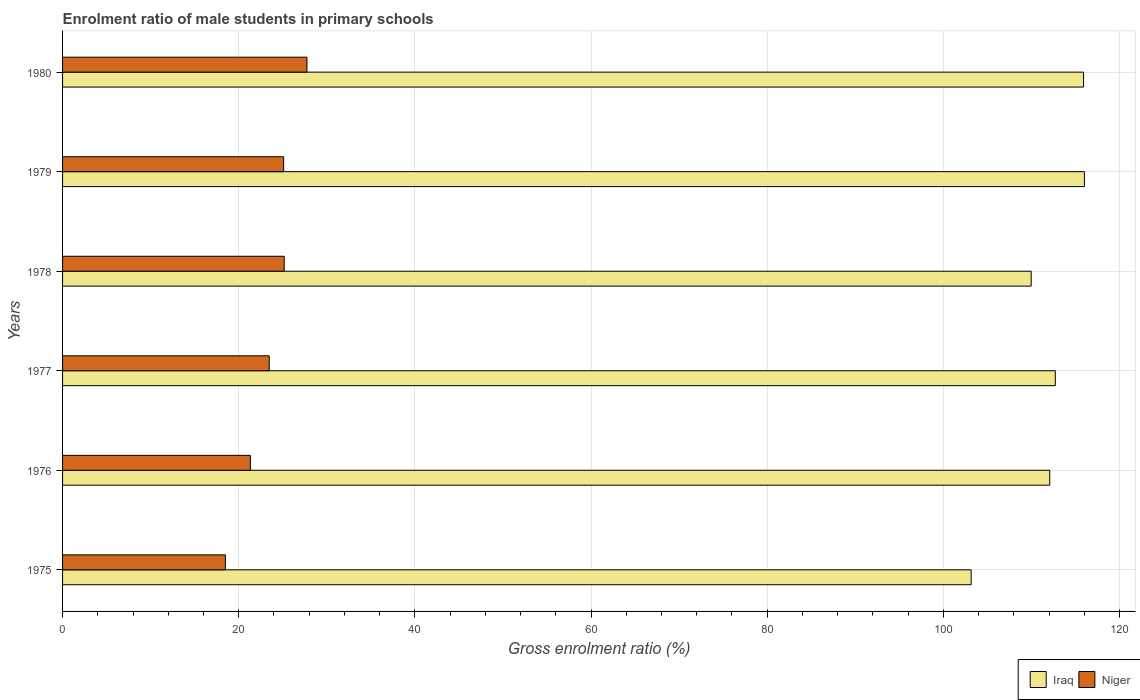How many different coloured bars are there?
Ensure brevity in your answer.  2. How many groups of bars are there?
Your answer should be very brief. 6. Are the number of bars on each tick of the Y-axis equal?
Give a very brief answer. Yes. In how many cases, is the number of bars for a given year not equal to the number of legend labels?
Offer a terse response. 0. What is the enrolment ratio of male students in primary schools in Niger in 1979?
Offer a terse response. 25.1. Across all years, what is the maximum enrolment ratio of male students in primary schools in Iraq?
Your answer should be very brief. 116.01. Across all years, what is the minimum enrolment ratio of male students in primary schools in Niger?
Ensure brevity in your answer.  18.49. In which year was the enrolment ratio of male students in primary schools in Niger maximum?
Offer a terse response. 1980. In which year was the enrolment ratio of male students in primary schools in Niger minimum?
Your answer should be compact. 1975. What is the total enrolment ratio of male students in primary schools in Iraq in the graph?
Keep it short and to the point. 669.84. What is the difference between the enrolment ratio of male students in primary schools in Niger in 1976 and that in 1980?
Ensure brevity in your answer.  -6.42. What is the difference between the enrolment ratio of male students in primary schools in Niger in 1980 and the enrolment ratio of male students in primary schools in Iraq in 1976?
Make the answer very short. -84.33. What is the average enrolment ratio of male students in primary schools in Iraq per year?
Your answer should be very brief. 111.64. In the year 1975, what is the difference between the enrolment ratio of male students in primary schools in Niger and enrolment ratio of male students in primary schools in Iraq?
Make the answer very short. -84.67. What is the ratio of the enrolment ratio of male students in primary schools in Iraq in 1976 to that in 1978?
Give a very brief answer. 1.02. What is the difference between the highest and the second highest enrolment ratio of male students in primary schools in Niger?
Ensure brevity in your answer.  2.58. What is the difference between the highest and the lowest enrolment ratio of male students in primary schools in Iraq?
Ensure brevity in your answer.  12.86. In how many years, is the enrolment ratio of male students in primary schools in Iraq greater than the average enrolment ratio of male students in primary schools in Iraq taken over all years?
Provide a succinct answer. 4. Is the sum of the enrolment ratio of male students in primary schools in Niger in 1976 and 1978 greater than the maximum enrolment ratio of male students in primary schools in Iraq across all years?
Offer a terse response. No. What does the 1st bar from the top in 1975 represents?
Provide a short and direct response. Niger. What does the 2nd bar from the bottom in 1977 represents?
Offer a terse response. Niger. How many bars are there?
Offer a very short reply. 12. Are all the bars in the graph horizontal?
Give a very brief answer. Yes. How many years are there in the graph?
Your answer should be compact. 6. What is the difference between two consecutive major ticks on the X-axis?
Make the answer very short. 20. Does the graph contain any zero values?
Your response must be concise. No. Does the graph contain grids?
Make the answer very short. Yes. Where does the legend appear in the graph?
Give a very brief answer. Bottom right. How many legend labels are there?
Provide a succinct answer. 2. How are the legend labels stacked?
Your answer should be compact. Horizontal. What is the title of the graph?
Offer a very short reply. Enrolment ratio of male students in primary schools. What is the label or title of the X-axis?
Make the answer very short. Gross enrolment ratio (%). What is the label or title of the Y-axis?
Your answer should be very brief. Years. What is the Gross enrolment ratio (%) in Iraq in 1975?
Make the answer very short. 103.15. What is the Gross enrolment ratio (%) in Niger in 1975?
Ensure brevity in your answer.  18.49. What is the Gross enrolment ratio (%) in Iraq in 1976?
Offer a terse response. 112.08. What is the Gross enrolment ratio (%) in Niger in 1976?
Offer a very short reply. 21.32. What is the Gross enrolment ratio (%) in Iraq in 1977?
Provide a short and direct response. 112.71. What is the Gross enrolment ratio (%) of Niger in 1977?
Keep it short and to the point. 23.46. What is the Gross enrolment ratio (%) in Iraq in 1978?
Give a very brief answer. 109.97. What is the Gross enrolment ratio (%) of Niger in 1978?
Your response must be concise. 25.16. What is the Gross enrolment ratio (%) in Iraq in 1979?
Your response must be concise. 116.01. What is the Gross enrolment ratio (%) in Niger in 1979?
Keep it short and to the point. 25.1. What is the Gross enrolment ratio (%) in Iraq in 1980?
Offer a very short reply. 115.92. What is the Gross enrolment ratio (%) of Niger in 1980?
Provide a succinct answer. 27.75. Across all years, what is the maximum Gross enrolment ratio (%) in Iraq?
Ensure brevity in your answer.  116.01. Across all years, what is the maximum Gross enrolment ratio (%) in Niger?
Your answer should be compact. 27.75. Across all years, what is the minimum Gross enrolment ratio (%) in Iraq?
Keep it short and to the point. 103.15. Across all years, what is the minimum Gross enrolment ratio (%) of Niger?
Keep it short and to the point. 18.49. What is the total Gross enrolment ratio (%) of Iraq in the graph?
Your response must be concise. 669.84. What is the total Gross enrolment ratio (%) of Niger in the graph?
Keep it short and to the point. 141.28. What is the difference between the Gross enrolment ratio (%) in Iraq in 1975 and that in 1976?
Offer a terse response. -8.92. What is the difference between the Gross enrolment ratio (%) of Niger in 1975 and that in 1976?
Offer a terse response. -2.84. What is the difference between the Gross enrolment ratio (%) of Iraq in 1975 and that in 1977?
Make the answer very short. -9.55. What is the difference between the Gross enrolment ratio (%) in Niger in 1975 and that in 1977?
Provide a short and direct response. -4.98. What is the difference between the Gross enrolment ratio (%) in Iraq in 1975 and that in 1978?
Your response must be concise. -6.81. What is the difference between the Gross enrolment ratio (%) in Niger in 1975 and that in 1978?
Keep it short and to the point. -6.68. What is the difference between the Gross enrolment ratio (%) in Iraq in 1975 and that in 1979?
Provide a short and direct response. -12.86. What is the difference between the Gross enrolment ratio (%) in Niger in 1975 and that in 1979?
Make the answer very short. -6.61. What is the difference between the Gross enrolment ratio (%) of Iraq in 1975 and that in 1980?
Give a very brief answer. -12.76. What is the difference between the Gross enrolment ratio (%) of Niger in 1975 and that in 1980?
Your answer should be very brief. -9.26. What is the difference between the Gross enrolment ratio (%) of Iraq in 1976 and that in 1977?
Provide a short and direct response. -0.63. What is the difference between the Gross enrolment ratio (%) in Niger in 1976 and that in 1977?
Give a very brief answer. -2.14. What is the difference between the Gross enrolment ratio (%) in Iraq in 1976 and that in 1978?
Your response must be concise. 2.11. What is the difference between the Gross enrolment ratio (%) in Niger in 1976 and that in 1978?
Your answer should be compact. -3.84. What is the difference between the Gross enrolment ratio (%) in Iraq in 1976 and that in 1979?
Your answer should be compact. -3.93. What is the difference between the Gross enrolment ratio (%) in Niger in 1976 and that in 1979?
Provide a succinct answer. -3.78. What is the difference between the Gross enrolment ratio (%) in Iraq in 1976 and that in 1980?
Keep it short and to the point. -3.84. What is the difference between the Gross enrolment ratio (%) of Niger in 1976 and that in 1980?
Your response must be concise. -6.42. What is the difference between the Gross enrolment ratio (%) of Iraq in 1977 and that in 1978?
Give a very brief answer. 2.74. What is the difference between the Gross enrolment ratio (%) in Niger in 1977 and that in 1978?
Offer a terse response. -1.7. What is the difference between the Gross enrolment ratio (%) in Iraq in 1977 and that in 1979?
Provide a succinct answer. -3.3. What is the difference between the Gross enrolment ratio (%) of Niger in 1977 and that in 1979?
Make the answer very short. -1.64. What is the difference between the Gross enrolment ratio (%) of Iraq in 1977 and that in 1980?
Ensure brevity in your answer.  -3.21. What is the difference between the Gross enrolment ratio (%) of Niger in 1977 and that in 1980?
Provide a succinct answer. -4.28. What is the difference between the Gross enrolment ratio (%) in Iraq in 1978 and that in 1979?
Offer a very short reply. -6.04. What is the difference between the Gross enrolment ratio (%) in Niger in 1978 and that in 1979?
Your answer should be very brief. 0.06. What is the difference between the Gross enrolment ratio (%) in Iraq in 1978 and that in 1980?
Give a very brief answer. -5.95. What is the difference between the Gross enrolment ratio (%) of Niger in 1978 and that in 1980?
Your answer should be compact. -2.58. What is the difference between the Gross enrolment ratio (%) of Iraq in 1979 and that in 1980?
Your answer should be very brief. 0.1. What is the difference between the Gross enrolment ratio (%) in Niger in 1979 and that in 1980?
Ensure brevity in your answer.  -2.65. What is the difference between the Gross enrolment ratio (%) of Iraq in 1975 and the Gross enrolment ratio (%) of Niger in 1976?
Provide a succinct answer. 81.83. What is the difference between the Gross enrolment ratio (%) in Iraq in 1975 and the Gross enrolment ratio (%) in Niger in 1977?
Ensure brevity in your answer.  79.69. What is the difference between the Gross enrolment ratio (%) of Iraq in 1975 and the Gross enrolment ratio (%) of Niger in 1978?
Your answer should be very brief. 77.99. What is the difference between the Gross enrolment ratio (%) of Iraq in 1975 and the Gross enrolment ratio (%) of Niger in 1979?
Provide a succinct answer. 78.05. What is the difference between the Gross enrolment ratio (%) in Iraq in 1975 and the Gross enrolment ratio (%) in Niger in 1980?
Ensure brevity in your answer.  75.41. What is the difference between the Gross enrolment ratio (%) in Iraq in 1976 and the Gross enrolment ratio (%) in Niger in 1977?
Make the answer very short. 88.61. What is the difference between the Gross enrolment ratio (%) in Iraq in 1976 and the Gross enrolment ratio (%) in Niger in 1978?
Make the answer very short. 86.91. What is the difference between the Gross enrolment ratio (%) in Iraq in 1976 and the Gross enrolment ratio (%) in Niger in 1979?
Provide a succinct answer. 86.98. What is the difference between the Gross enrolment ratio (%) in Iraq in 1976 and the Gross enrolment ratio (%) in Niger in 1980?
Provide a short and direct response. 84.33. What is the difference between the Gross enrolment ratio (%) in Iraq in 1977 and the Gross enrolment ratio (%) in Niger in 1978?
Your answer should be very brief. 87.54. What is the difference between the Gross enrolment ratio (%) of Iraq in 1977 and the Gross enrolment ratio (%) of Niger in 1979?
Make the answer very short. 87.61. What is the difference between the Gross enrolment ratio (%) in Iraq in 1977 and the Gross enrolment ratio (%) in Niger in 1980?
Offer a terse response. 84.96. What is the difference between the Gross enrolment ratio (%) of Iraq in 1978 and the Gross enrolment ratio (%) of Niger in 1979?
Provide a short and direct response. 84.87. What is the difference between the Gross enrolment ratio (%) in Iraq in 1978 and the Gross enrolment ratio (%) in Niger in 1980?
Keep it short and to the point. 82.22. What is the difference between the Gross enrolment ratio (%) in Iraq in 1979 and the Gross enrolment ratio (%) in Niger in 1980?
Your answer should be compact. 88.27. What is the average Gross enrolment ratio (%) of Iraq per year?
Your answer should be compact. 111.64. What is the average Gross enrolment ratio (%) in Niger per year?
Ensure brevity in your answer.  23.55. In the year 1975, what is the difference between the Gross enrolment ratio (%) of Iraq and Gross enrolment ratio (%) of Niger?
Keep it short and to the point. 84.67. In the year 1976, what is the difference between the Gross enrolment ratio (%) in Iraq and Gross enrolment ratio (%) in Niger?
Offer a terse response. 90.76. In the year 1977, what is the difference between the Gross enrolment ratio (%) in Iraq and Gross enrolment ratio (%) in Niger?
Offer a very short reply. 89.24. In the year 1978, what is the difference between the Gross enrolment ratio (%) in Iraq and Gross enrolment ratio (%) in Niger?
Your response must be concise. 84.81. In the year 1979, what is the difference between the Gross enrolment ratio (%) of Iraq and Gross enrolment ratio (%) of Niger?
Ensure brevity in your answer.  90.91. In the year 1980, what is the difference between the Gross enrolment ratio (%) of Iraq and Gross enrolment ratio (%) of Niger?
Provide a succinct answer. 88.17. What is the ratio of the Gross enrolment ratio (%) in Iraq in 1975 to that in 1976?
Make the answer very short. 0.92. What is the ratio of the Gross enrolment ratio (%) in Niger in 1975 to that in 1976?
Provide a short and direct response. 0.87. What is the ratio of the Gross enrolment ratio (%) in Iraq in 1975 to that in 1977?
Your answer should be very brief. 0.92. What is the ratio of the Gross enrolment ratio (%) of Niger in 1975 to that in 1977?
Offer a terse response. 0.79. What is the ratio of the Gross enrolment ratio (%) in Iraq in 1975 to that in 1978?
Offer a very short reply. 0.94. What is the ratio of the Gross enrolment ratio (%) in Niger in 1975 to that in 1978?
Your answer should be very brief. 0.73. What is the ratio of the Gross enrolment ratio (%) in Iraq in 1975 to that in 1979?
Provide a short and direct response. 0.89. What is the ratio of the Gross enrolment ratio (%) of Niger in 1975 to that in 1979?
Provide a succinct answer. 0.74. What is the ratio of the Gross enrolment ratio (%) in Iraq in 1975 to that in 1980?
Offer a terse response. 0.89. What is the ratio of the Gross enrolment ratio (%) in Niger in 1975 to that in 1980?
Provide a succinct answer. 0.67. What is the ratio of the Gross enrolment ratio (%) of Iraq in 1976 to that in 1977?
Ensure brevity in your answer.  0.99. What is the ratio of the Gross enrolment ratio (%) in Niger in 1976 to that in 1977?
Keep it short and to the point. 0.91. What is the ratio of the Gross enrolment ratio (%) of Iraq in 1976 to that in 1978?
Ensure brevity in your answer.  1.02. What is the ratio of the Gross enrolment ratio (%) of Niger in 1976 to that in 1978?
Ensure brevity in your answer.  0.85. What is the ratio of the Gross enrolment ratio (%) in Iraq in 1976 to that in 1979?
Your answer should be very brief. 0.97. What is the ratio of the Gross enrolment ratio (%) of Niger in 1976 to that in 1979?
Your response must be concise. 0.85. What is the ratio of the Gross enrolment ratio (%) of Iraq in 1976 to that in 1980?
Provide a short and direct response. 0.97. What is the ratio of the Gross enrolment ratio (%) in Niger in 1976 to that in 1980?
Offer a terse response. 0.77. What is the ratio of the Gross enrolment ratio (%) in Iraq in 1977 to that in 1978?
Give a very brief answer. 1.02. What is the ratio of the Gross enrolment ratio (%) in Niger in 1977 to that in 1978?
Offer a very short reply. 0.93. What is the ratio of the Gross enrolment ratio (%) of Iraq in 1977 to that in 1979?
Offer a terse response. 0.97. What is the ratio of the Gross enrolment ratio (%) in Niger in 1977 to that in 1979?
Make the answer very short. 0.93. What is the ratio of the Gross enrolment ratio (%) in Iraq in 1977 to that in 1980?
Offer a terse response. 0.97. What is the ratio of the Gross enrolment ratio (%) of Niger in 1977 to that in 1980?
Your answer should be very brief. 0.85. What is the ratio of the Gross enrolment ratio (%) in Iraq in 1978 to that in 1979?
Your response must be concise. 0.95. What is the ratio of the Gross enrolment ratio (%) of Iraq in 1978 to that in 1980?
Ensure brevity in your answer.  0.95. What is the ratio of the Gross enrolment ratio (%) in Niger in 1978 to that in 1980?
Offer a terse response. 0.91. What is the ratio of the Gross enrolment ratio (%) in Niger in 1979 to that in 1980?
Keep it short and to the point. 0.9. What is the difference between the highest and the second highest Gross enrolment ratio (%) of Iraq?
Ensure brevity in your answer.  0.1. What is the difference between the highest and the second highest Gross enrolment ratio (%) of Niger?
Offer a very short reply. 2.58. What is the difference between the highest and the lowest Gross enrolment ratio (%) in Iraq?
Give a very brief answer. 12.86. What is the difference between the highest and the lowest Gross enrolment ratio (%) of Niger?
Your response must be concise. 9.26. 